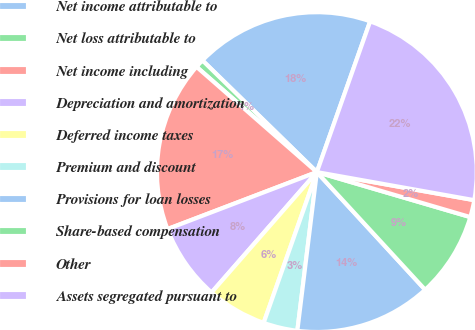<chart> <loc_0><loc_0><loc_500><loc_500><pie_chart><fcel>Net income attributable to<fcel>Net loss attributable to<fcel>Net income including<fcel>Depreciation and amortization<fcel>Deferred income taxes<fcel>Premium and discount<fcel>Provisions for loan losses<fcel>Share-based compensation<fcel>Other<fcel>Assets segregated pursuant to<nl><fcel>18.1%<fcel>0.87%<fcel>17.24%<fcel>7.76%<fcel>6.04%<fcel>3.45%<fcel>13.79%<fcel>8.62%<fcel>1.73%<fcel>22.4%<nl></chart> 